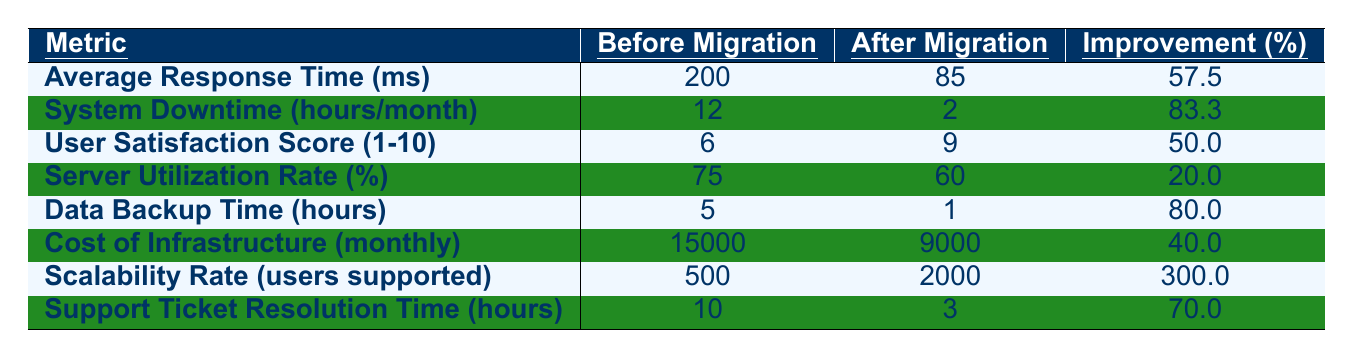What was the average response time before migration? The table indicates the average response time (200 ms) before migration in the corresponding row.
Answer: 200 ms What is the improvement percentage for system downtime? The table shows an improvement percentage of 83.3% for system downtime, calculated from the before and after values (12 hours to 2 hours).
Answer: 83.3% Did the user satisfaction score increase after migration? Comparing the before (6) and after (9) values in the table shows that the user satisfaction score did indeed increase, confirming the improvement.
Answer: Yes What is the difference in cost of infrastructure before and after migration? The cost before migration was 15000 and after migration it was 9000. The difference is 15000 - 9000 = 6000.
Answer: 6000 What is the new average response time after migration? The table lists the average response time after migration as 85 ms.
Answer: 85 ms How much did the scalability rate increase in terms of users supported? The scalability rate increased from 500 to 2000 users. The increase can be calculated: 2000 - 500 = 1500 users.
Answer: 1500 users What was the percentage improvement for data backup time? The table documents an 80% improvement for data backup time, which is directly stated under the improvement percentage column.
Answer: 80% Which metric had the highest improvement percentage after migration? By reviewing the improvement percentages, the scalability rate shows the highest improvement at 300%.
Answer: Scalability Rate What is the overall percentage improvement across all metrics listed? To find the overall improvement, average the listed improvement percentages: (57.5 + 83.3 + 50 + 20 + 80 + 40 + 300 + 70)/8 = 77.66%.
Answer: 77.66% Did the server utilization rate decrease after migration? The before value (75%) and the after value (60%) indicate a decrease in the server utilization rate, confirming the change.
Answer: Yes What is the reduction in support ticket resolution time after migration? The reduction can be calculated by subtracting the after value (3 hours) from the before value (10 hours): 10 - 3 = 7 hours.
Answer: 7 hours 